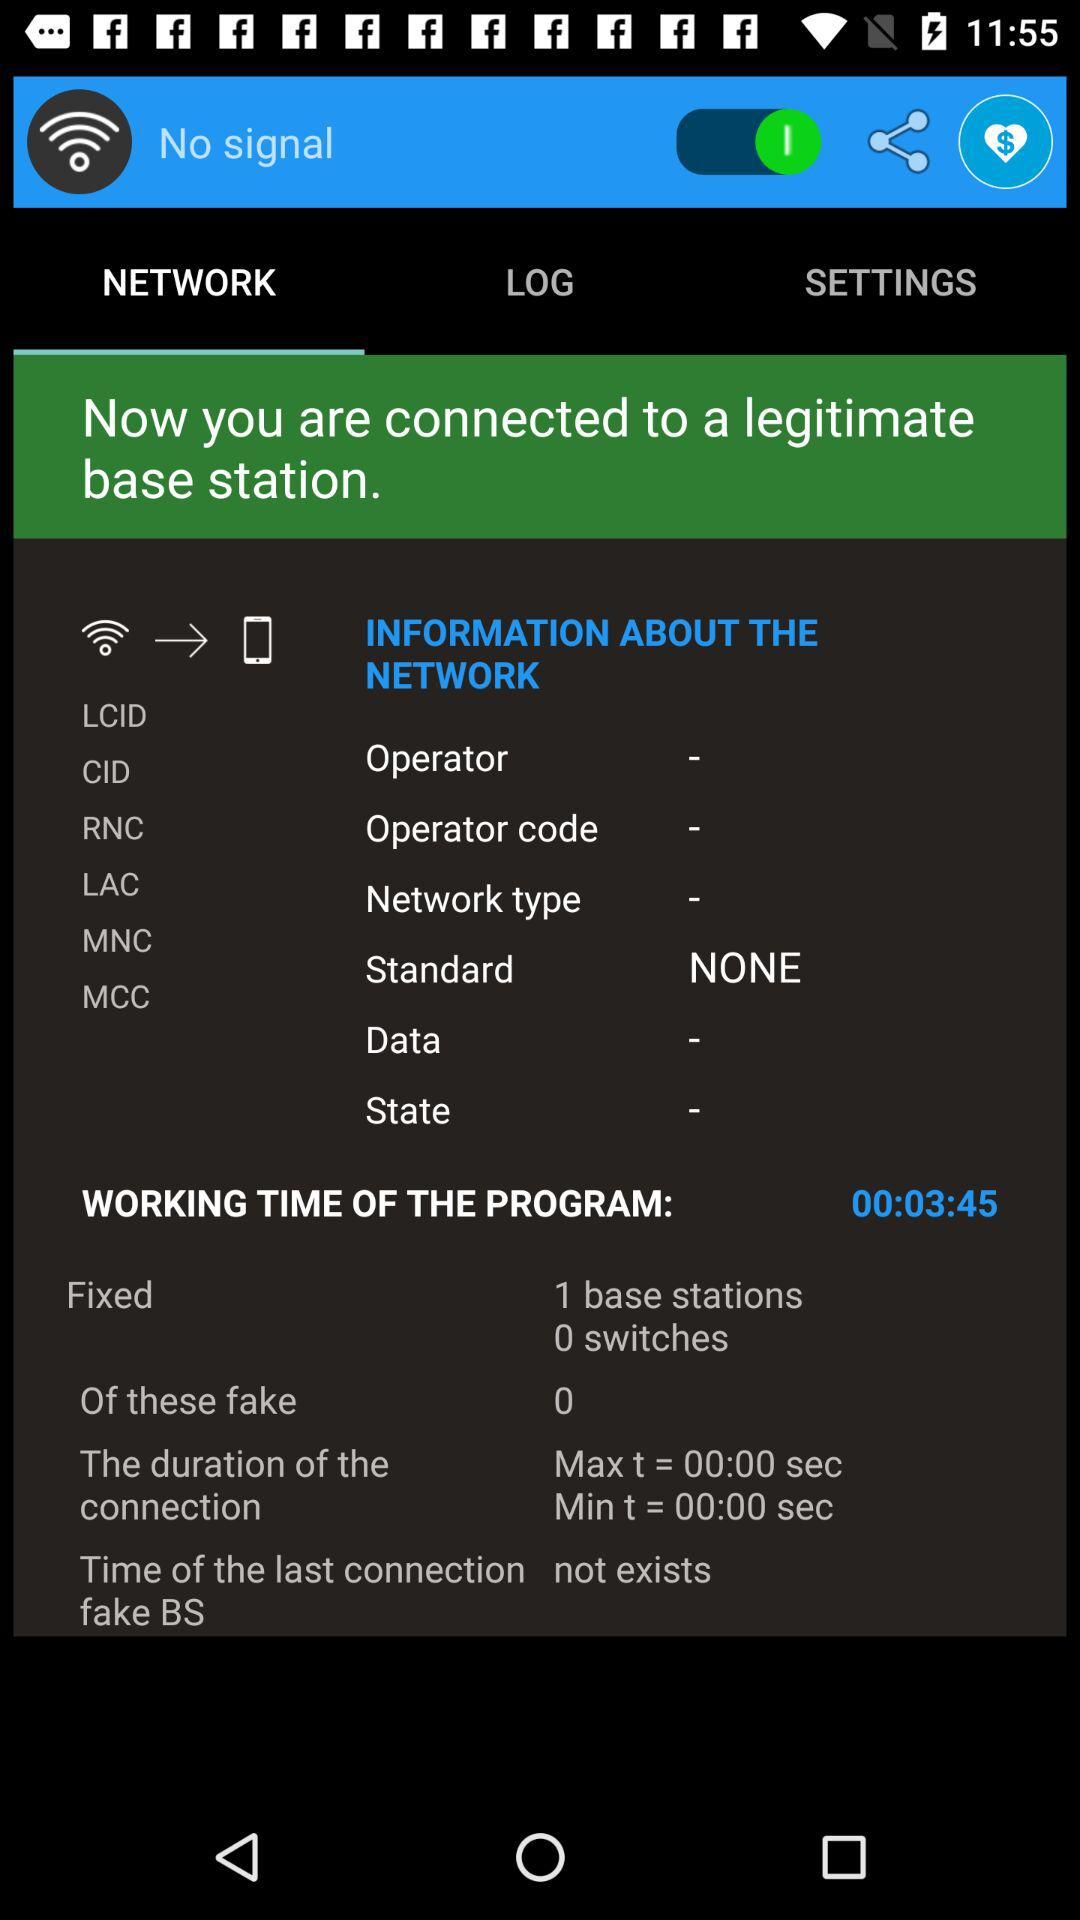Which applications are available for sharing?
When the provided information is insufficient, respond with <no answer>. <no answer> 